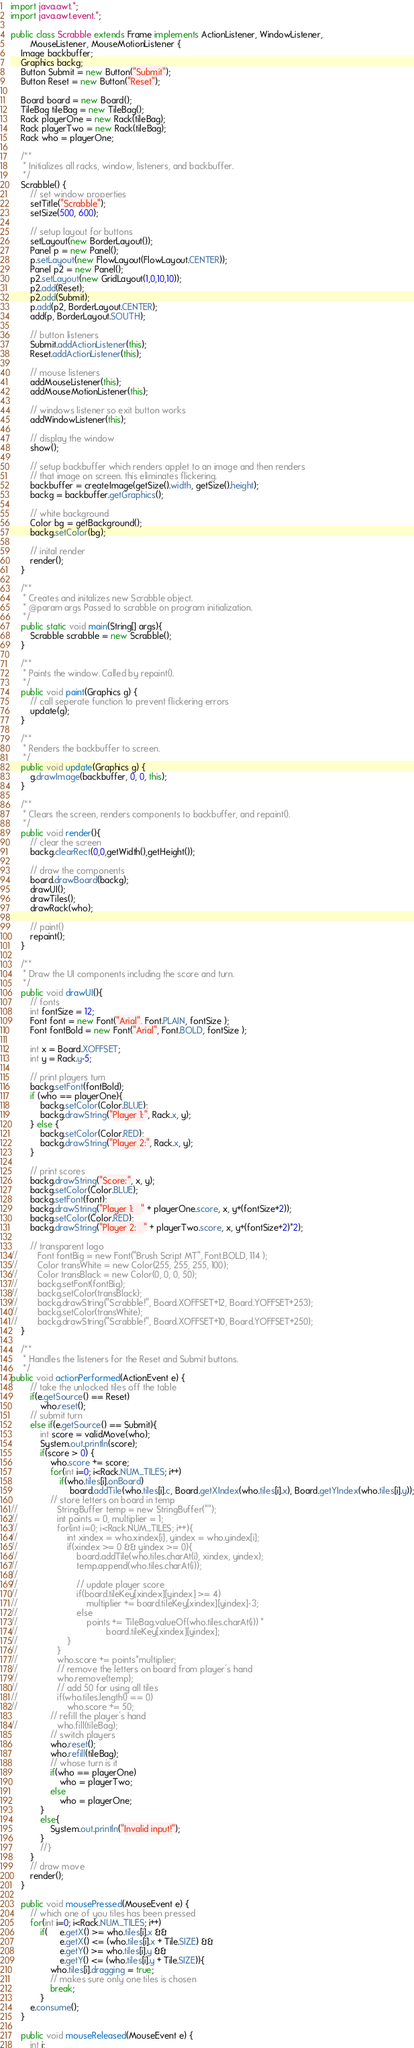Convert code to text. <code><loc_0><loc_0><loc_500><loc_500><_Java_>
import java.awt.*;
import java.awt.event.*;

public class Scrabble extends Frame implements ActionListener, WindowListener,
        MouseListener, MouseMotionListener {
    Image backbuffer;
    Graphics backg;
    Button Submit = new Button("Submit");
    Button Reset = new Button("Reset");

    Board board = new Board();
    TileBag tileBag = new TileBag();
    Rack playerOne = new Rack(tileBag);
    Rack playerTwo = new Rack(tileBag);
    Rack who = playerOne;

    /**
     * Initializes all racks, window, listeners, and backbuffer.
     */
    Scrabble() {
        // set window properties
        setTitle("Scrabble");
        setSize(500, 600);

        // setup layout for buttons
        setLayout(new BorderLayout());
        Panel p = new Panel();
        p.setLayout(new FlowLayout(FlowLayout.CENTER));
        Panel p2 = new Panel();
        p2.setLayout(new GridLayout(1,0,10,10));
        p2.add(Reset);
        p2.add(Submit);
        p.add(p2, BorderLayout.CENTER);
        add(p, BorderLayout.SOUTH);

        // button listeners
        Submit.addActionListener(this);
        Reset.addActionListener(this);

        // mouse listeners
        addMouseListener(this);
        addMouseMotionListener(this);

        // windows listener so exit button works
        addWindowListener(this);

        // display the window
        show();

        // setup backbuffer which renders applet to an image and then renders
        // that image on screen. this eliminates flickering.
        backbuffer = createImage(getSize().width, getSize().height);
        backg = backbuffer.getGraphics();

        // white background
        Color bg = getBackground();
        backg.setColor(bg);

        // inital render
        render();
    }

    /**
     * Creates and initalizes new Scrabble object.
     * @param args Passed to scrabble on program initialization.
     */
    public static void main(String[] args){
        Scrabble scrabble = new Scrabble();
    }

    /**
     * Paints the window. Called by repaint().
     */
    public void paint(Graphics g) {
        // call seperate function to prevent flickering errors
        update(g);
    }

    /**
     * Renders the backbuffer to screen.
     */
    public void update(Graphics g) {
        g.drawImage(backbuffer, 0, 0, this);
    }

    /**
     * Clears the screen, renders components to backbuffer, and repaint().
     */
    public void render(){
        // clear the screen
        backg.clearRect(0,0,getWidth(),getHeight());

        // draw the components
        board.drawBoard(backg);
        drawUI();
        drawTiles();
        drawRack(who);

        // paint()
        repaint();
    }

    /**
     * Draw the UI components including the score and turn.
     */
    public void drawUI(){
        // fonts
        int fontSize = 12;
        Font font = new Font("Arial", Font.PLAIN, fontSize );
        Font fontBold = new Font("Arial", Font.BOLD, fontSize );

        int x = Board.XOFFSET;
        int y = Rack.y-5;

        // print players turn
        backg.setFont(fontBold);
        if (who == playerOne){
            backg.setColor(Color.BLUE);
            backg.drawString("Player 1:", Rack.x, y);
        } else {
            backg.setColor(Color.RED);
            backg.drawString("Player 2:", Rack.x, y);
        }
        
        // print scores
        backg.drawString("Score:", x, y);
        backg.setColor(Color.BLUE);
        backg.setFont(font);
        backg.drawString("Player 1:   " + playerOne.score, x, y+(fontSize+2));
        backg.setColor(Color.RED);
        backg.drawString("Player 2:   " + playerTwo.score, x, y+(fontSize+2)*2);

        // transparent logo
//        Font fontBig = new Font("Brush Script MT", Font.BOLD, 114 );
//        Color transWhite = new Color(255, 255, 255, 100);
//        Color transBlack = new Color(0, 0, 0, 50);
//        backg.setFont(fontBig);
//        backg.setColor(transBlack);
//        backg.drawString("Scrabble!", Board.XOFFSET+12, Board.YOFFSET+253);
//        backg.setColor(transWhite);
//        backg.drawString("Scrabble!", Board.XOFFSET+10, Board.YOFFSET+250);
    }

    /**
     * Handles the listeners for the Reset and Submit buttons.
     */
public void actionPerformed(ActionEvent e) {
        // take the unlocked tiles off the table
        if(e.getSource() == Reset)
            who.reset();
        // submit turn
        else if(e.getSource() == Submit){
            int score = validMove(who);
            System.out.println(score);
            if(score > 0) {
                who.score += score;
                for(int i=0; i<Rack.NUM_TILES; i++)
                    if(who.tiles[i].onBoard)
                        board.addTile(who.tiles[i].c, Board.getXIndex(who.tiles[i].x), Board.getYIndex(who.tiles[i].y));
                // store letters on board in temp
//                StringBuffer temp = new StringBuffer("");
//                int points = 0, multiplier = 1;
//                for(int i=0; i<Rack.NUM_TILES; i++){
//                    int xindex = who.xindex[i], yindex = who.yindex[i];
//                    if(xindex >= 0 && yindex >= 0){
//                        board.addTile(who.tiles.charAt(i), xindex, yindex);
//                        temp.append(who.tiles.charAt(i));
//    
//                        // update player score
//                        if(board.tileKey[xindex][yindex] >= 4)
//                            multiplier += board.tileKey[xindex][yindex]-3;
//                        else
//                            points += TileBag.valueOf(who.tiles.charAt(i)) *
//                                    board.tileKey[xindex][yindex];
//                    }
//                }
//                who.score += points*multiplier;
//                // remove the letters on board from player's hand
//                who.remove(temp);
//                // add 50 for using all tiles
//                if(who.tiles.length() == 0)
//                    who.score += 50;
                // refill the player's hand
//                who.fill(tileBag);
                // switch players
                who.reset();
                who.refill(tileBag);
                // whose turn is it
                if(who == playerOne)
                    who = playerTwo;
                else
                    who = playerOne;
            }
            else{
                System.out.println("Invalid input!");
            }
            //}
        }
        // draw move
        render();
    }

    public void mousePressed(MouseEvent e) {
        // which one of you tiles has been pressed
        for(int i=0; i<Rack.NUM_TILES; i++)
            if(     e.getX() >= who.tiles[i].x &&
                    e.getX() <= (who.tiles[i].x + Tile.SIZE) &&
                    e.getY() >= who.tiles[i].y &&
                    e.getY() <= (who.tiles[i].y + Tile.SIZE)){
                who.tiles[i].dragging = true;
                // makes sure only one tiles is chosen
                break;
            }
        e.consume();
    }

    public void mouseReleased(MouseEvent e) {
        int i;</code> 